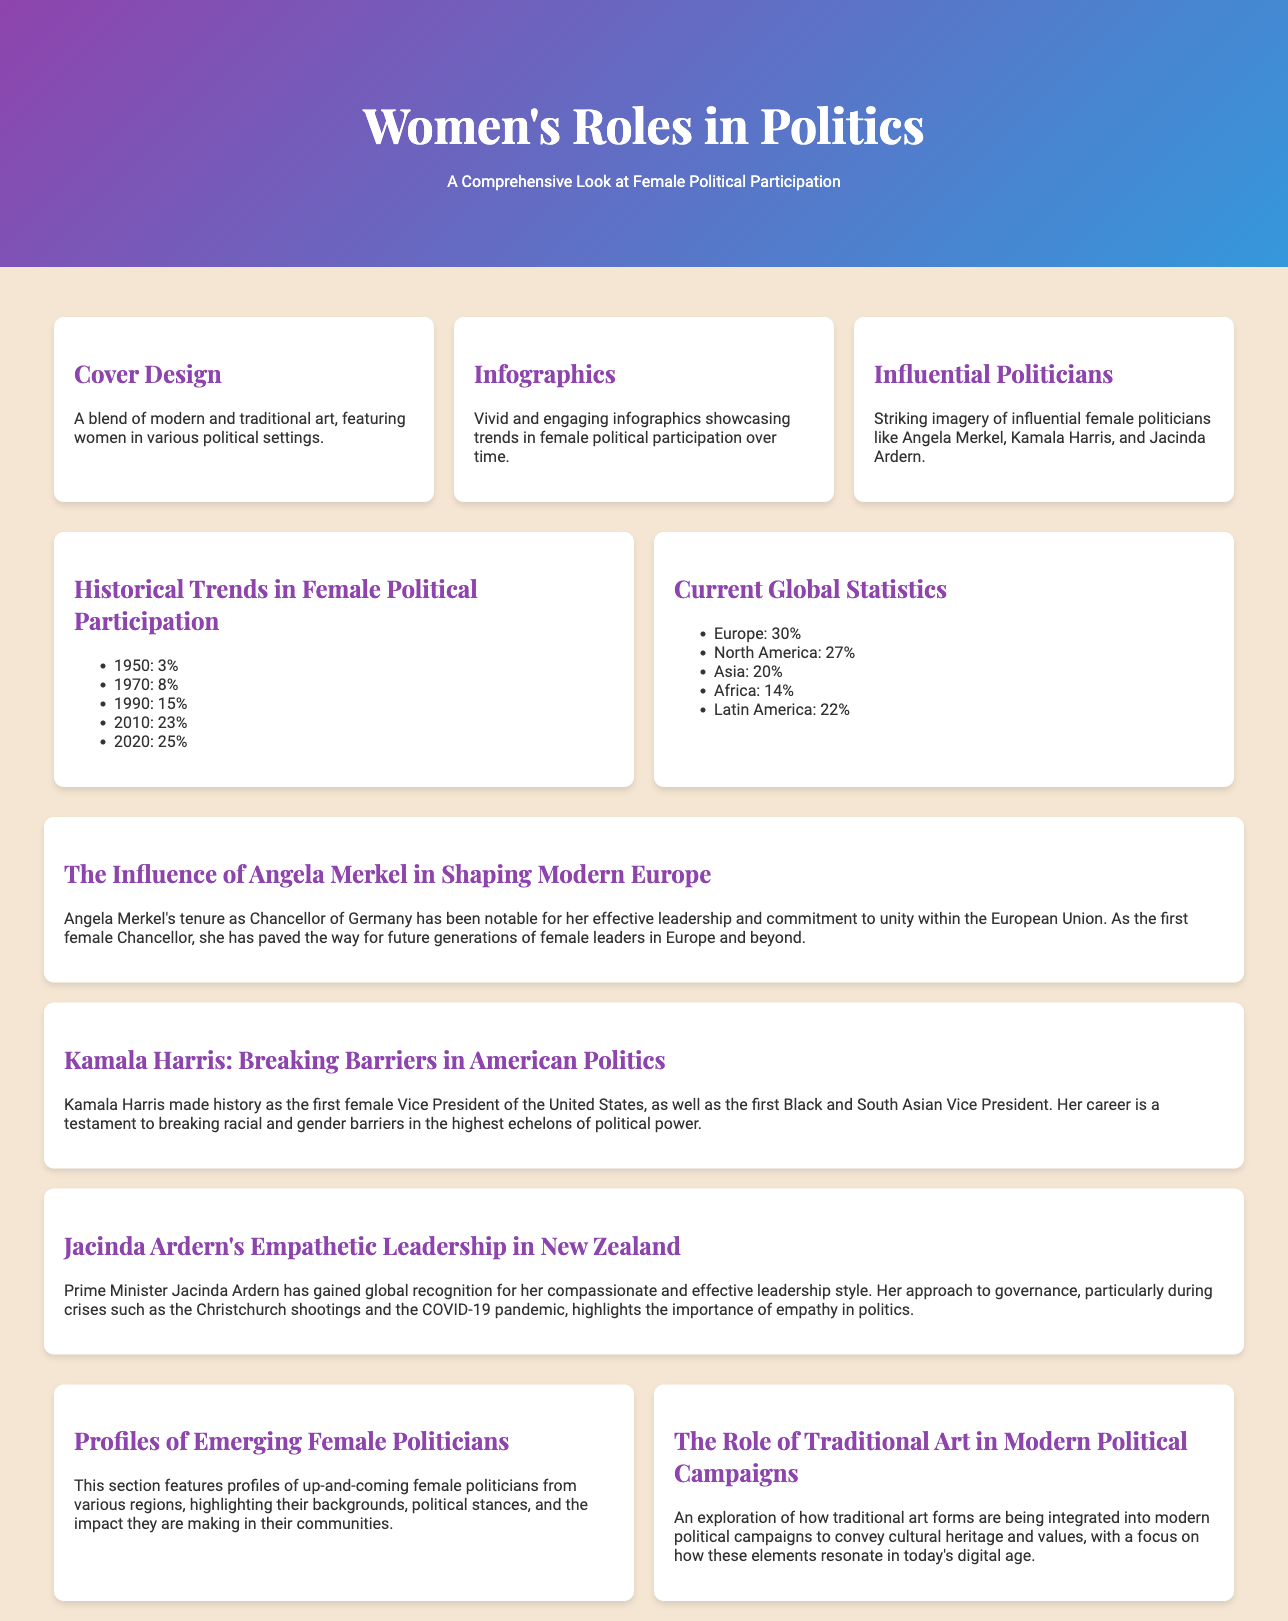What is the title of the magazine? The title is given in the header of the document, indicating the focus on women's roles in politics.
Answer: Women's Roles in Politics Who is featured in the imagery of the cover? The document mentions influential female politicians whose imagery is present on the cover.
Answer: Angela Merkel, Kamala Harris, Jacinda Ardern What was the percentage of female political participation in 1950? The infographic presents specific historical data regarding female political participation.
Answer: 3% What is the percentage of female political participation in Latin America according to current global statistics? The infographic provides the latest statistics for female political participation by region.
Answer: 22% Which politician is highlighted for breaking barriers in American politics? The feature article specifies the contributions of an individual politician known for breaking barriers.
Answer: Kamala Harris What role does traditional art play in modern political campaigns? The section discusses how traditional art is integrated into political campaigns, focusing on cultural heritage and values.
Answer: Cultural heritage and values How does Jacinda Ardern's leadership style contribute to her global recognition? The article describes her compassionate approach during crises as an influential factor in her recognition.
Answer: Empathetic leadership What is the publication's focus as stated in the subtitle? The subtitle clarifies the overarching theme of the magazine regarding female engagement in politics.
Answer: A Comprehensive Look at Female Political Participation 